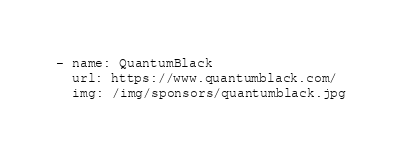Convert code to text. <code><loc_0><loc_0><loc_500><loc_500><_YAML_>- name: QuantumBlack
  url: https://www.quantumblack.com/
  img: /img/sponsors/quantumblack.jpg
</code> 